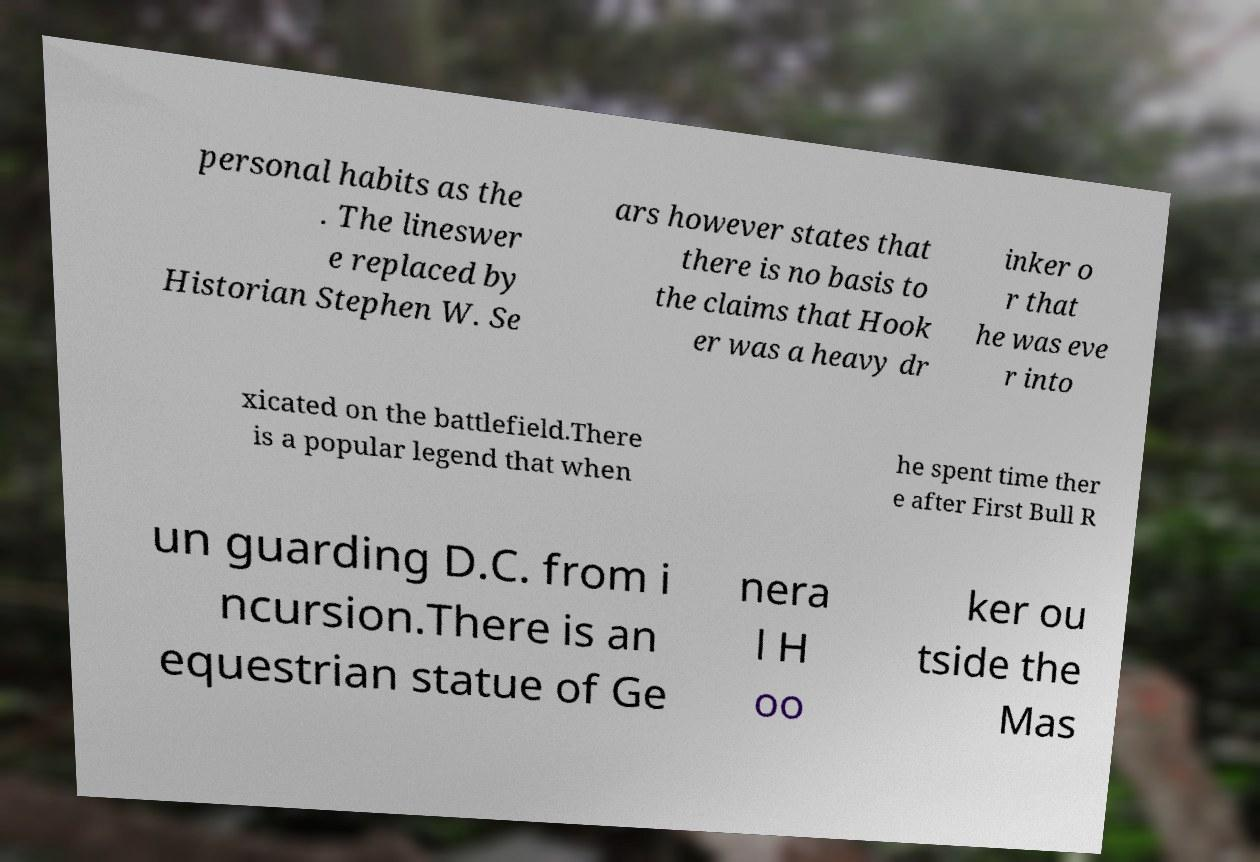Could you extract and type out the text from this image? personal habits as the . The lineswer e replaced by Historian Stephen W. Se ars however states that there is no basis to the claims that Hook er was a heavy dr inker o r that he was eve r into xicated on the battlefield.There is a popular legend that when he spent time ther e after First Bull R un guarding D.C. from i ncursion.There is an equestrian statue of Ge nera l H oo ker ou tside the Mas 